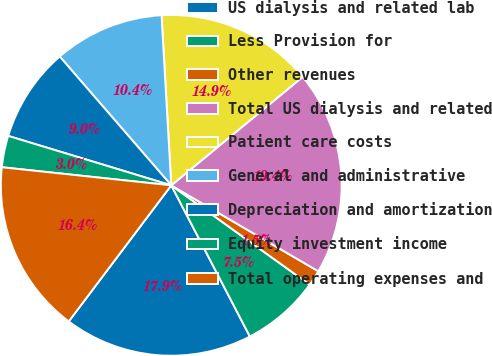Convert chart. <chart><loc_0><loc_0><loc_500><loc_500><pie_chart><fcel>US dialysis and related lab<fcel>Less Provision for<fcel>Other revenues<fcel>Total US dialysis and related<fcel>Patient care costs<fcel>General and administrative<fcel>Depreciation and amortization<fcel>Equity investment income<fcel>Total operating expenses and<nl><fcel>17.91%<fcel>7.46%<fcel>1.49%<fcel>19.4%<fcel>14.93%<fcel>10.45%<fcel>8.96%<fcel>2.99%<fcel>16.42%<nl></chart> 